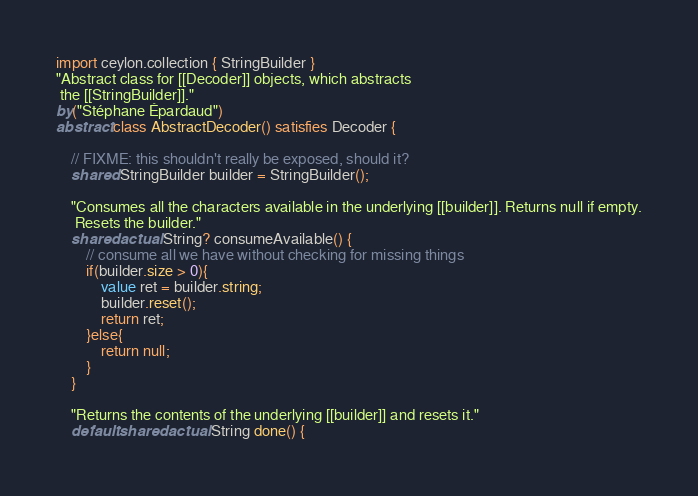<code> <loc_0><loc_0><loc_500><loc_500><_Ceylon_>import ceylon.collection { StringBuilder }
"Abstract class for [[Decoder]] objects, which abstracts
 the [[StringBuilder]]."
by("Stéphane Épardaud")
abstract class AbstractDecoder() satisfies Decoder {
    
    // FIXME: this shouldn't really be exposed, should it?
    shared StringBuilder builder = StringBuilder();

    "Consumes all the characters available in the underlying [[builder]]. Returns null if empty.
     Resets the builder."
    shared actual String? consumeAvailable() {
        // consume all we have without checking for missing things
        if(builder.size > 0){
            value ret = builder.string;
            builder.reset();
            return ret;
        }else{
            return null;
        }
    }

    "Returns the contents of the underlying [[builder]] and resets it."
    default shared actual String done() {</code> 